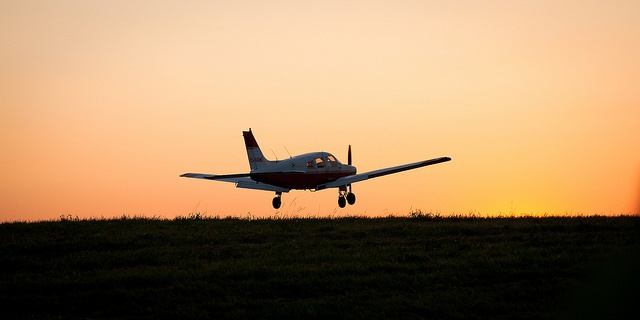Describe the objects in this image and their specific colors. I can see a airplane in tan, black, gray, and darkblue tones in this image. 